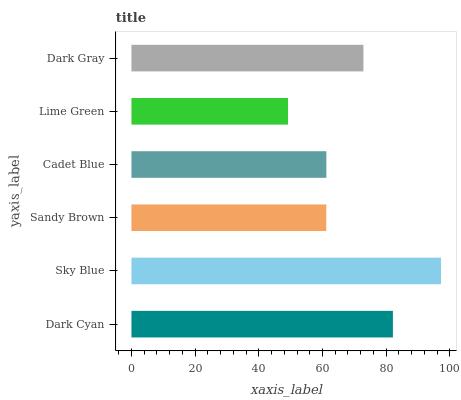Is Lime Green the minimum?
Answer yes or no. Yes. Is Sky Blue the maximum?
Answer yes or no. Yes. Is Sandy Brown the minimum?
Answer yes or no. No. Is Sandy Brown the maximum?
Answer yes or no. No. Is Sky Blue greater than Sandy Brown?
Answer yes or no. Yes. Is Sandy Brown less than Sky Blue?
Answer yes or no. Yes. Is Sandy Brown greater than Sky Blue?
Answer yes or no. No. Is Sky Blue less than Sandy Brown?
Answer yes or no. No. Is Dark Gray the high median?
Answer yes or no. Yes. Is Cadet Blue the low median?
Answer yes or no. Yes. Is Sky Blue the high median?
Answer yes or no. No. Is Sandy Brown the low median?
Answer yes or no. No. 